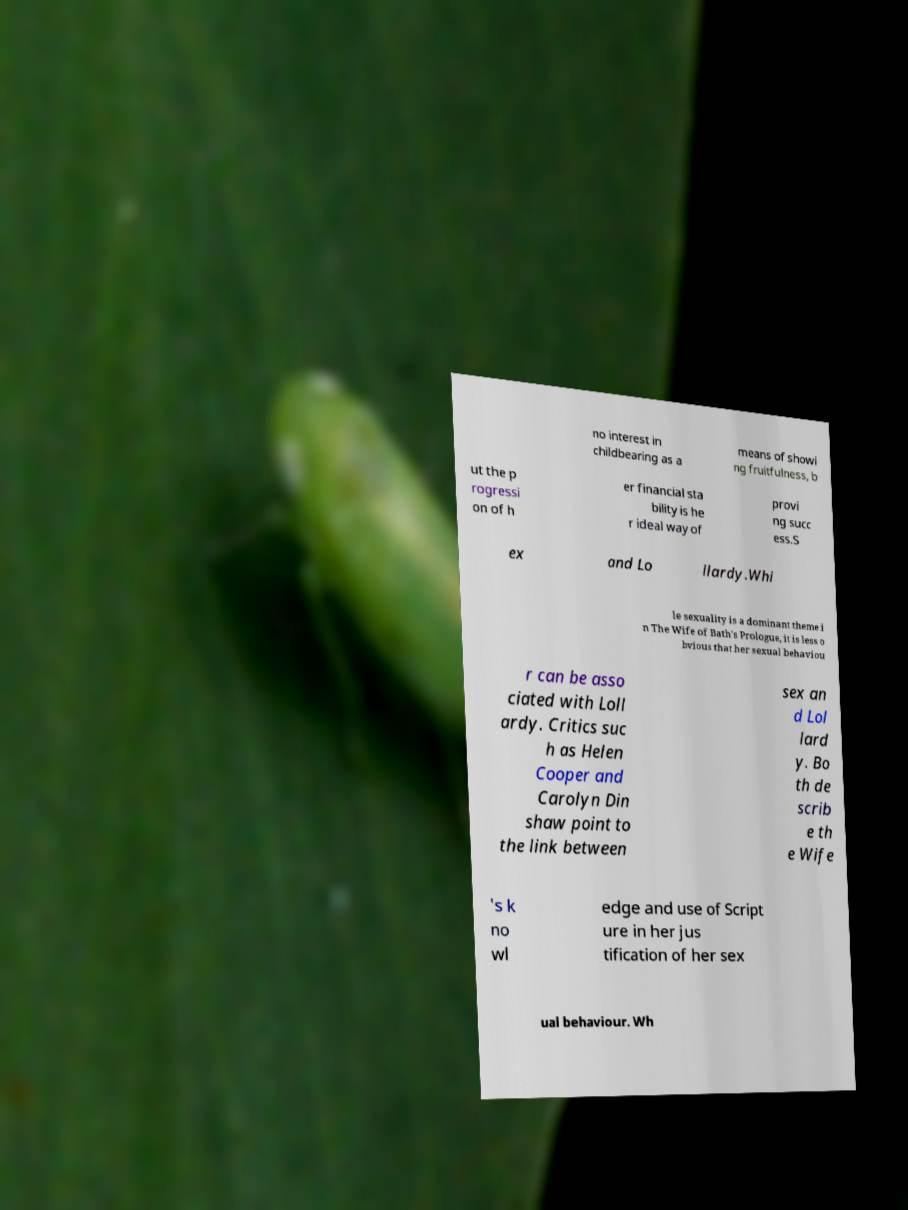Could you extract and type out the text from this image? no interest in childbearing as a means of showi ng fruitfulness, b ut the p rogressi on of h er financial sta bility is he r ideal way of provi ng succ ess.S ex and Lo llardy.Whi le sexuality is a dominant theme i n The Wife of Bath's Prologue, it is less o bvious that her sexual behaviou r can be asso ciated with Loll ardy. Critics suc h as Helen Cooper and Carolyn Din shaw point to the link between sex an d Lol lard y. Bo th de scrib e th e Wife 's k no wl edge and use of Script ure in her jus tification of her sex ual behaviour. Wh 